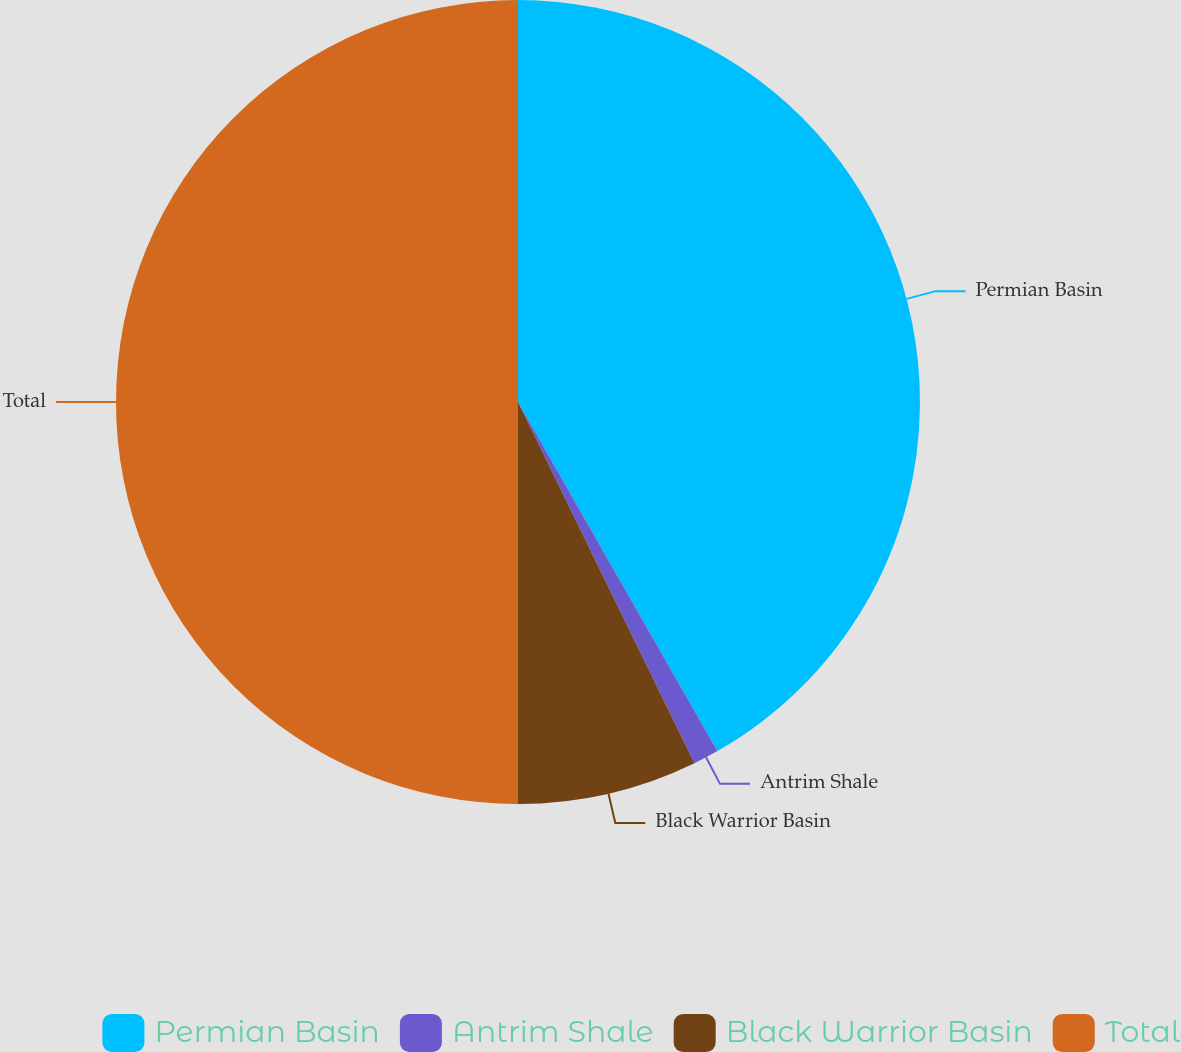Convert chart to OTSL. <chart><loc_0><loc_0><loc_500><loc_500><pie_chart><fcel>Permian Basin<fcel>Antrim Shale<fcel>Black Warrior Basin<fcel>Total<nl><fcel>41.74%<fcel>1.03%<fcel>7.23%<fcel>50.0%<nl></chart> 